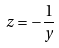Convert formula to latex. <formula><loc_0><loc_0><loc_500><loc_500>z = - \frac { 1 } { y }</formula> 